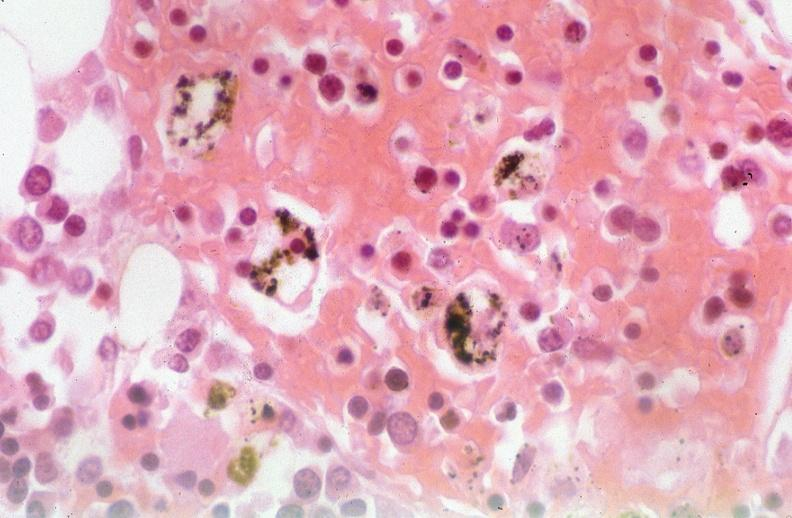where is this?
Answer the question using a single word or phrase. Lung 